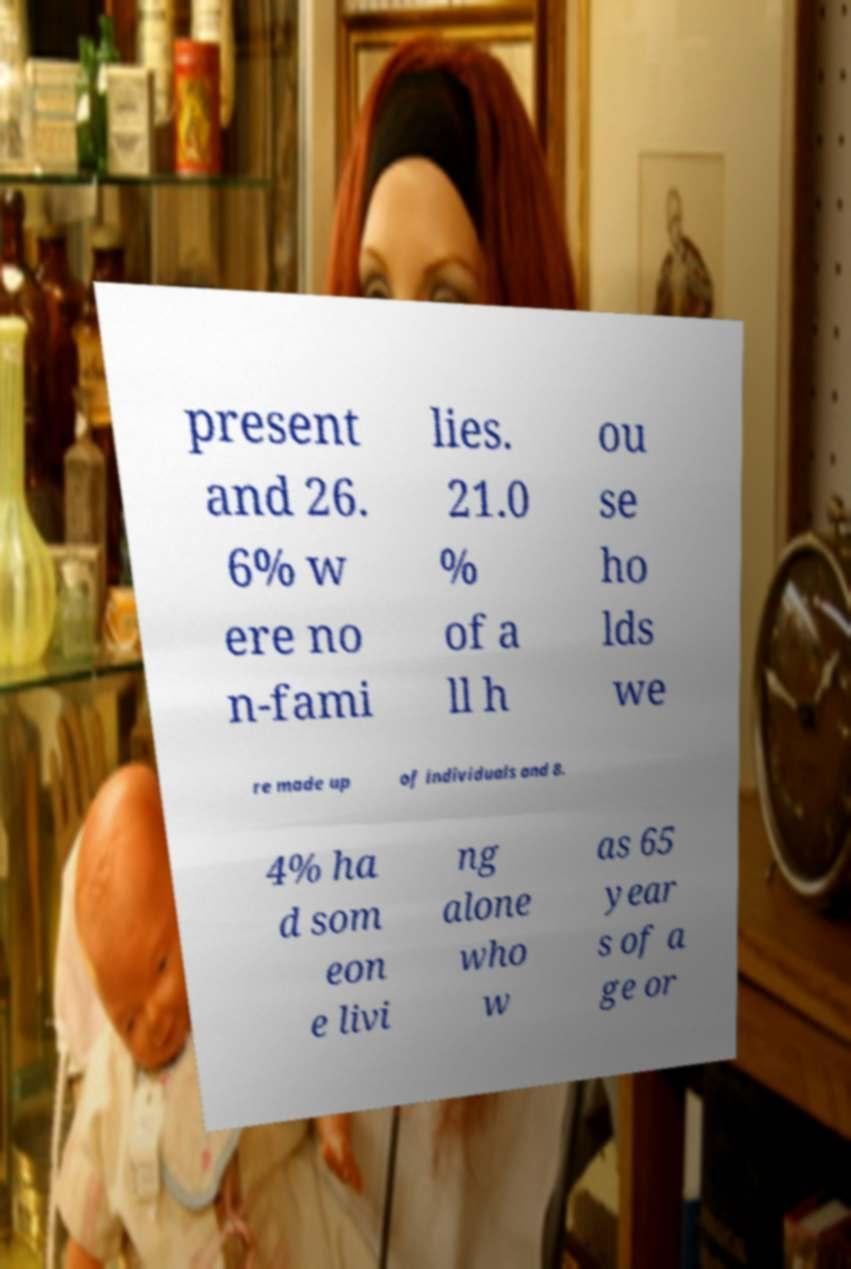Please identify and transcribe the text found in this image. present and 26. 6% w ere no n-fami lies. 21.0 % of a ll h ou se ho lds we re made up of individuals and 8. 4% ha d som eon e livi ng alone who w as 65 year s of a ge or 